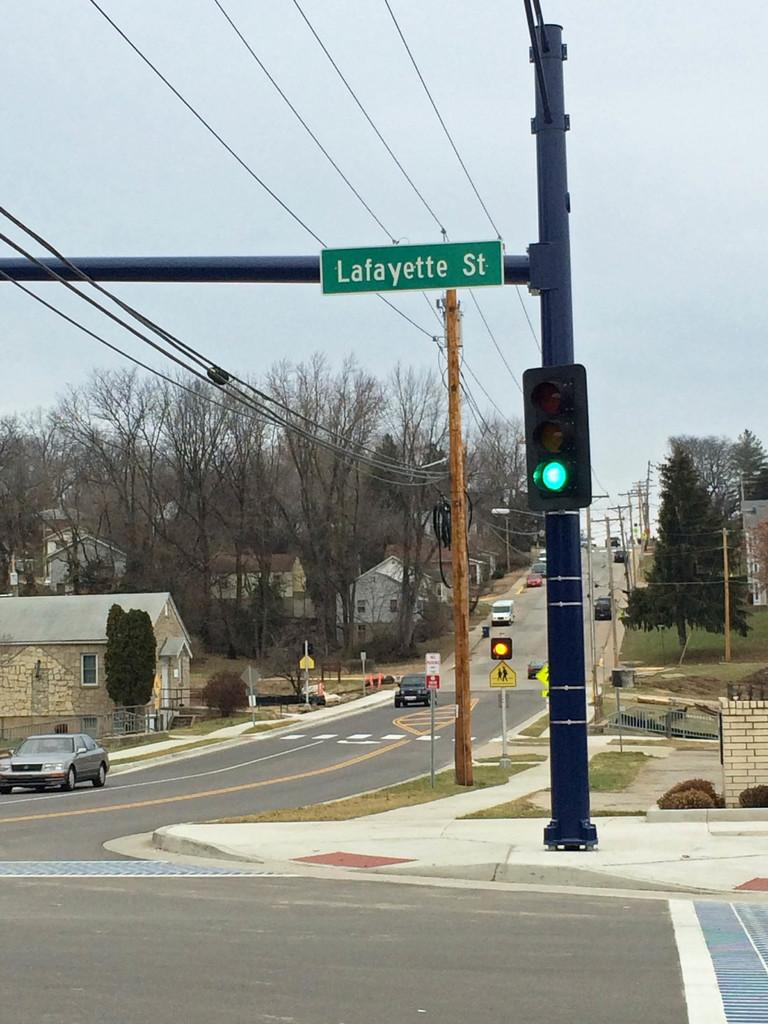<image>
Relay a brief, clear account of the picture shown. An intersection at Lafayette Street with a yellow light in the background. 